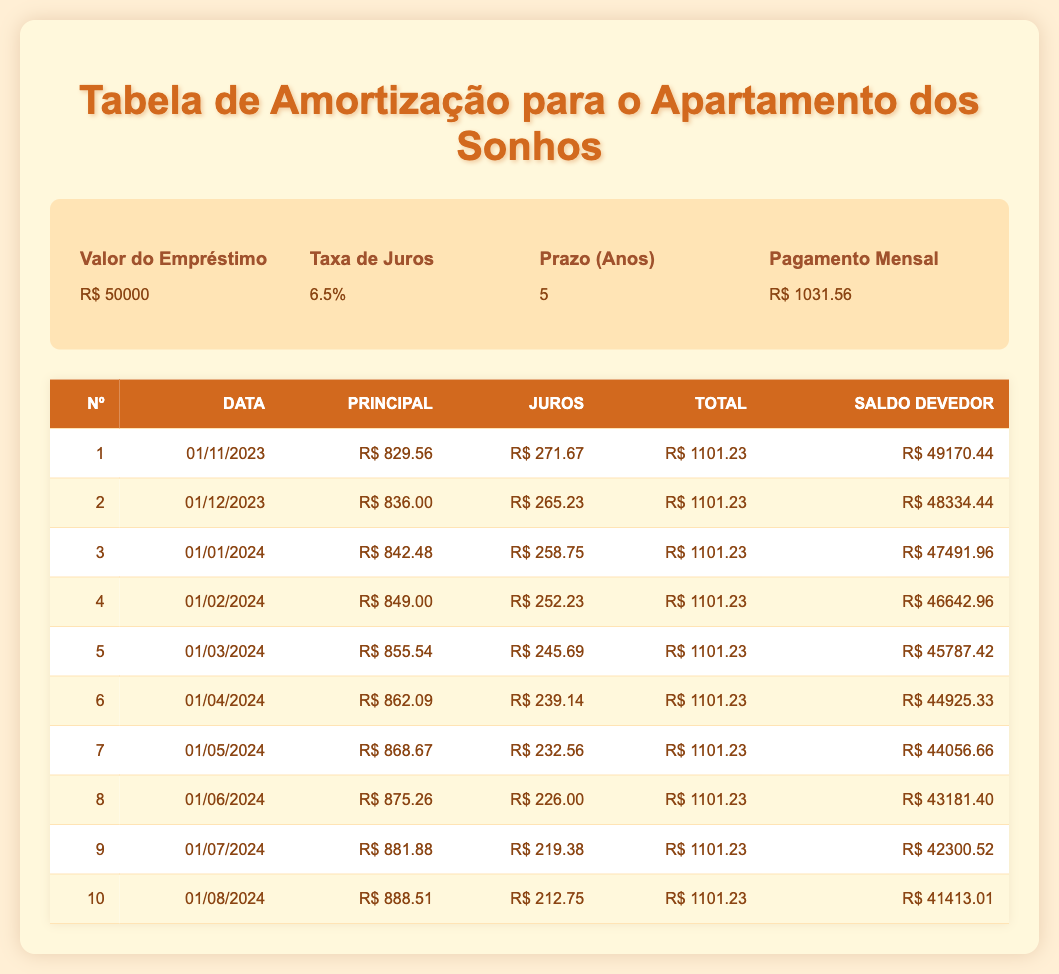What is the total amount paid in the first month? The total payment for the first month is directly given in the table as 1101.23.
Answer: 1101.23 What is the remaining balance after the second payment? The remaining balance after the second payment is listed as 48334.44 in the table.
Answer: 48334.44 How much was paid in principal over the first three payments? To find the total principal paid over the first three payments, we add the principal payments: 829.56 + 836.00 + 842.48 = 2508.04.
Answer: 2508.04 Did the amount paid in interest decrease from the first payment to the second? In the first payment, the interest payment is 271.67, and in the second payment, it is 265.23. Since 265.23 is less than 271.67, the interest amount decreased.
Answer: Yes What is the average monthly principal payment over the first six payments? We find the total principal payments for the first six months: 829.56 + 836.00 + 842.48 + 849.00 + 855.54 + 862.09 = 5074.67. Dividing this sum by 6 gives us an average of 845.78.
Answer: 845.78 What is the decrease in the remaining balance from the seventh to the eighth payment? The remaining balance after the seventh payment is 44056.66, and after the eighth payment, it is 43181.40. The decrease is 44056.66 - 43181.40 = 875.26.
Answer: 875.26 Is the total payment of 1101.23 consistent across the first ten payments? By looking at the table, each payment has a total of 1101.23 listed in its row, confirming the consistency.
Answer: Yes What is the difference between the principal payments of the first and last payment in this set? The principal payment for the first payment is 829.56, and for the last (tenth) payment, it is 888.51. The difference is 888.51 - 829.56 = 58.95.
Answer: 58.95 How much total interest has been paid after four months? To find the total interest after four months, we add: 271.67 + 265.23 + 258.75 + 252.23 = 1047.88.
Answer: 1047.88 